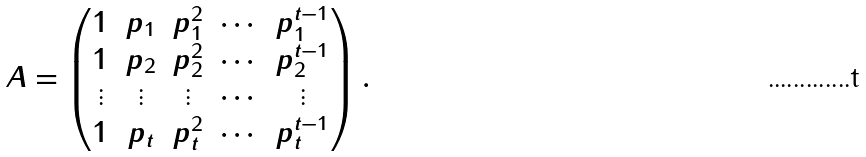Convert formula to latex. <formula><loc_0><loc_0><loc_500><loc_500>A = \begin{pmatrix} 1 & p _ { 1 } & p _ { 1 } ^ { 2 } & \cdots & p _ { 1 } ^ { t - 1 } \\ 1 & p _ { 2 } & p _ { 2 } ^ { 2 } & \cdots & p _ { 2 } ^ { t - 1 } \\ \vdots & \vdots & \vdots & \cdots & \vdots \\ 1 & p _ { t } & p _ { t } ^ { 2 } & \cdots & p _ { t } ^ { t - 1 } \end{pmatrix} .</formula> 